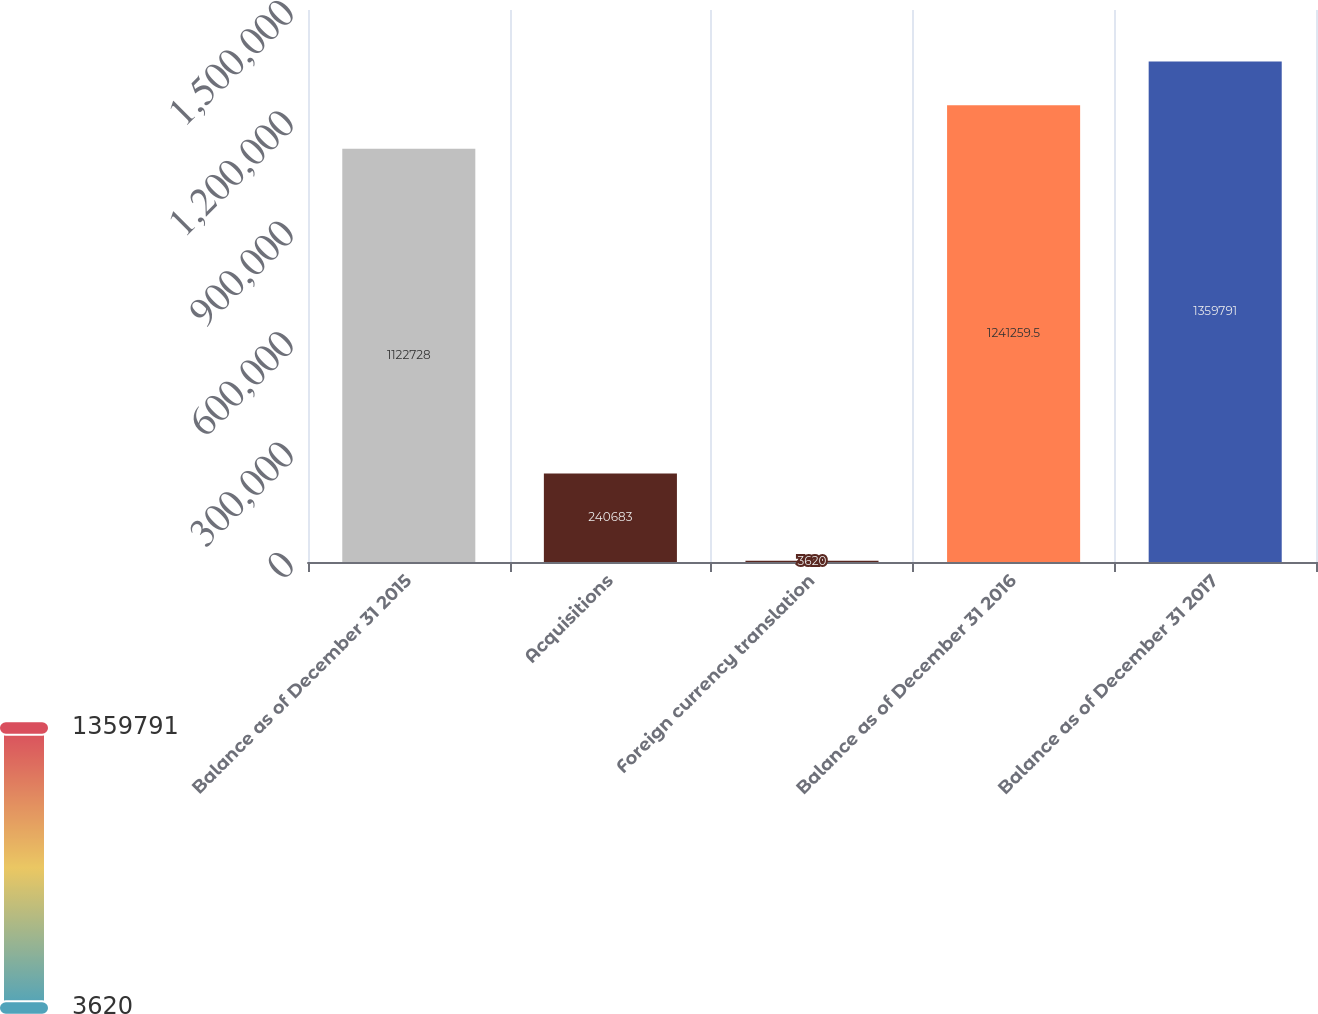Convert chart. <chart><loc_0><loc_0><loc_500><loc_500><bar_chart><fcel>Balance as of December 31 2015<fcel>Acquisitions<fcel>Foreign currency translation<fcel>Balance as of December 31 2016<fcel>Balance as of December 31 2017<nl><fcel>1.12273e+06<fcel>240683<fcel>3620<fcel>1.24126e+06<fcel>1.35979e+06<nl></chart> 